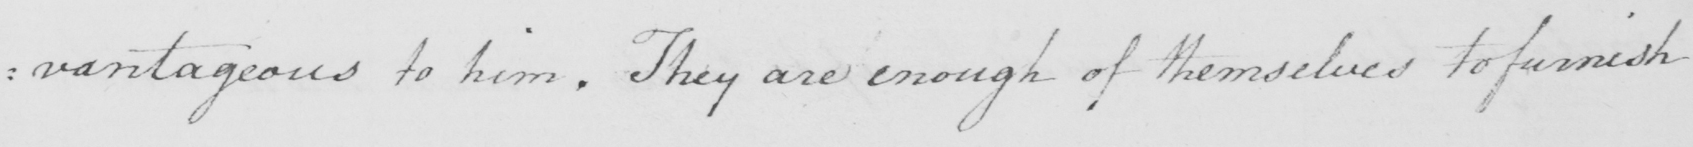Can you tell me what this handwritten text says? : vantageous to him . They are enough of themselves to furnish 